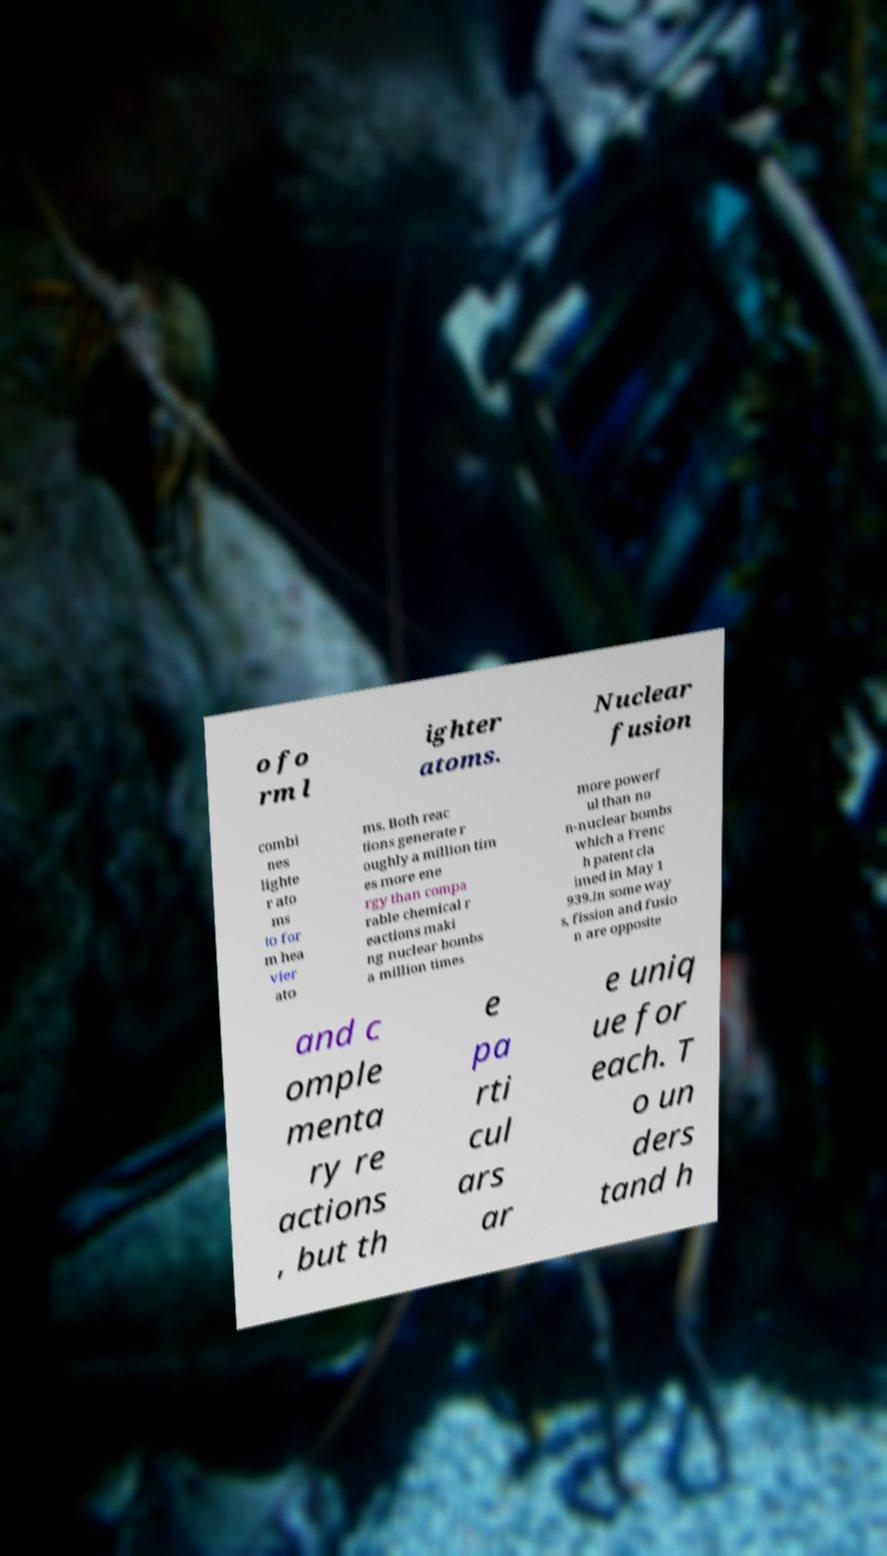What messages or text are displayed in this image? I need them in a readable, typed format. o fo rm l ighter atoms. Nuclear fusion combi nes lighte r ato ms to for m hea vier ato ms. Both reac tions generate r oughly a million tim es more ene rgy than compa rable chemical r eactions maki ng nuclear bombs a million times more powerf ul than no n-nuclear bombs which a Frenc h patent cla imed in May 1 939.In some way s, fission and fusio n are opposite and c omple menta ry re actions , but th e pa rti cul ars ar e uniq ue for each. T o un ders tand h 